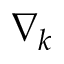Convert formula to latex. <formula><loc_0><loc_0><loc_500><loc_500>\nabla _ { k }</formula> 